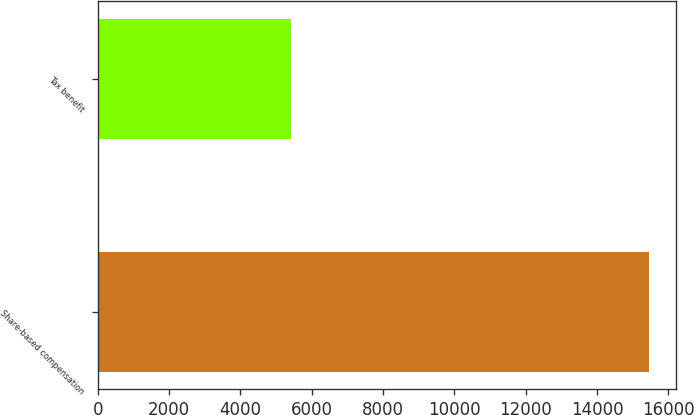<chart> <loc_0><loc_0><loc_500><loc_500><bar_chart><fcel>Share-based compensation<fcel>Tax benefit<nl><fcel>15453<fcel>5408<nl></chart> 